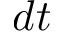<formula> <loc_0><loc_0><loc_500><loc_500>d t</formula> 